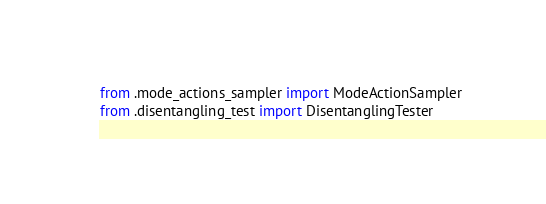Convert code to text. <code><loc_0><loc_0><loc_500><loc_500><_Python_>from .mode_actions_sampler import ModeActionSampler
from .disentangling_test import DisentanglingTester</code> 